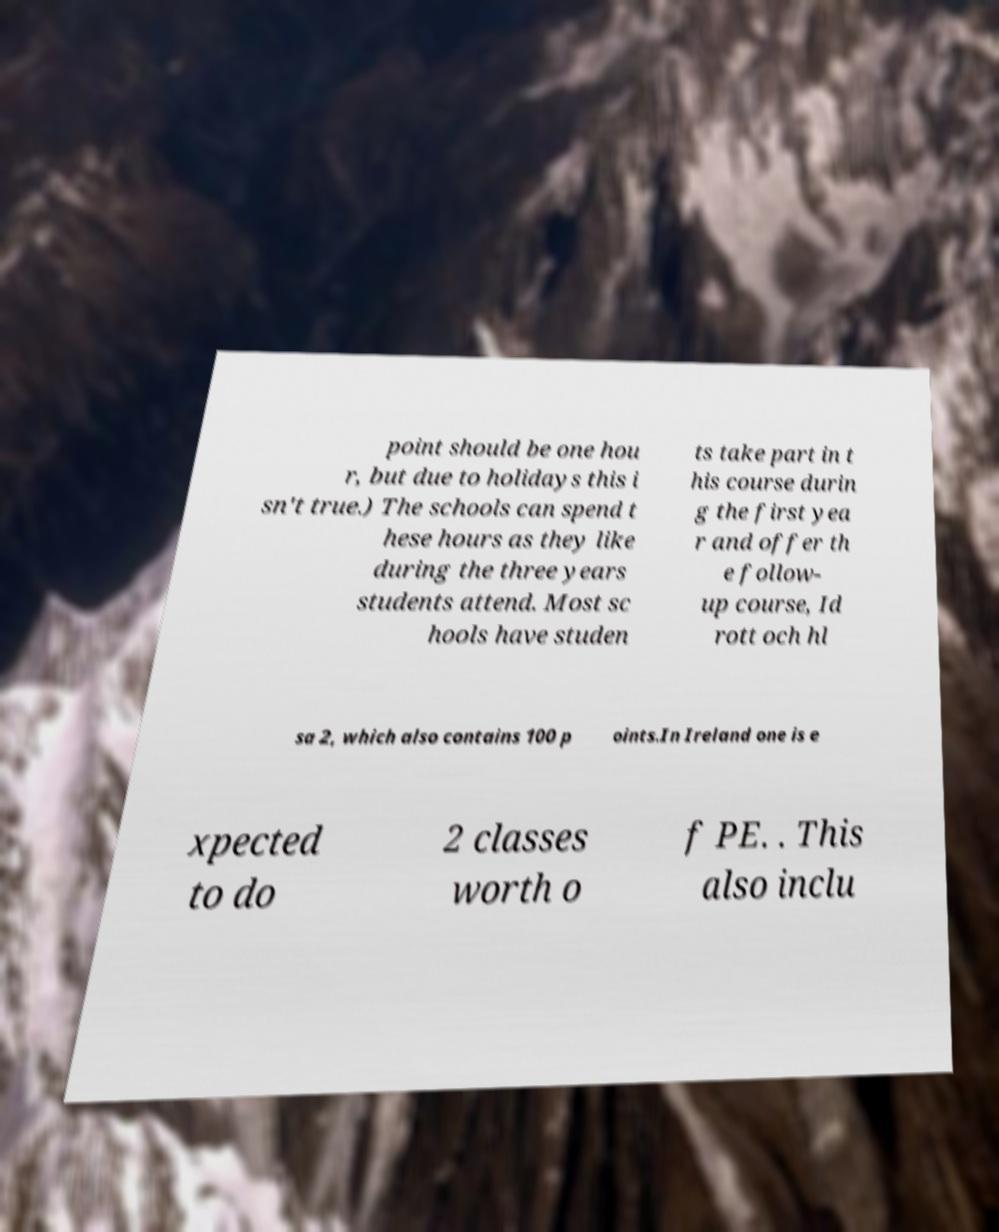I need the written content from this picture converted into text. Can you do that? point should be one hou r, but due to holidays this i sn't true.) The schools can spend t hese hours as they like during the three years students attend. Most sc hools have studen ts take part in t his course durin g the first yea r and offer th e follow- up course, Id rott och hl sa 2, which also contains 100 p oints.In Ireland one is e xpected to do 2 classes worth o f PE. . This also inclu 